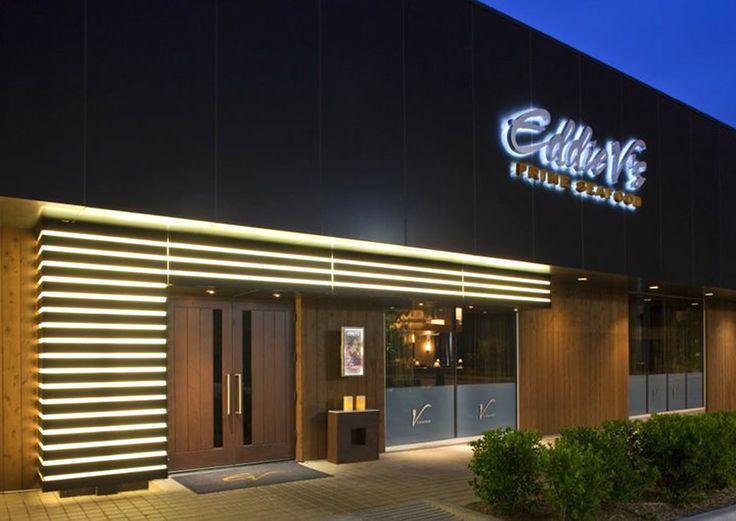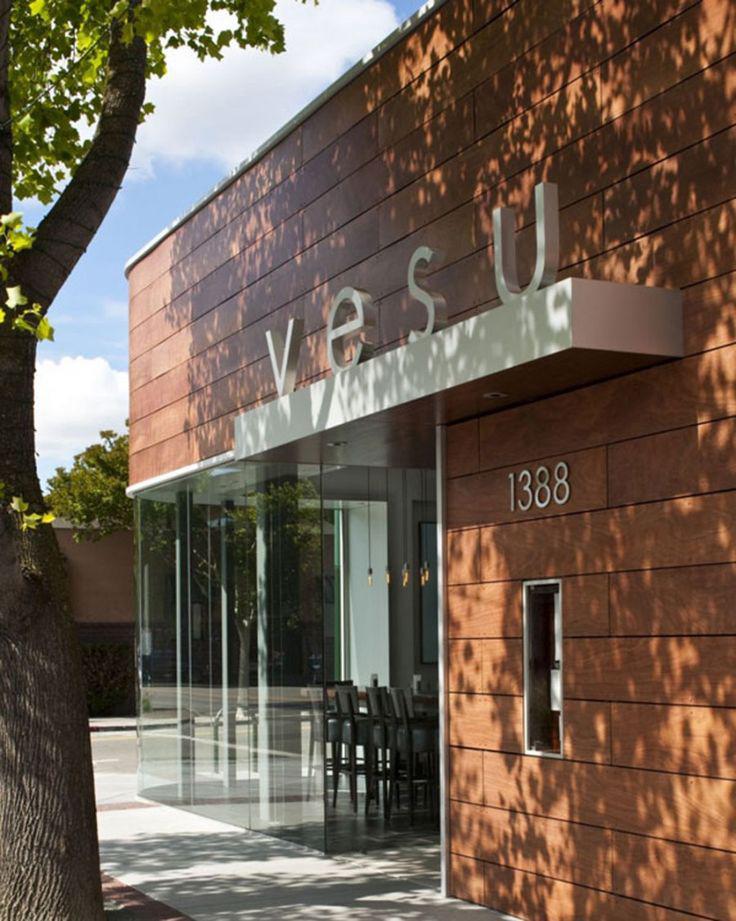The first image is the image on the left, the second image is the image on the right. Given the left and right images, does the statement "The numbers for the address can be seen outside the building in one of the images." hold true? Answer yes or no. Yes. 